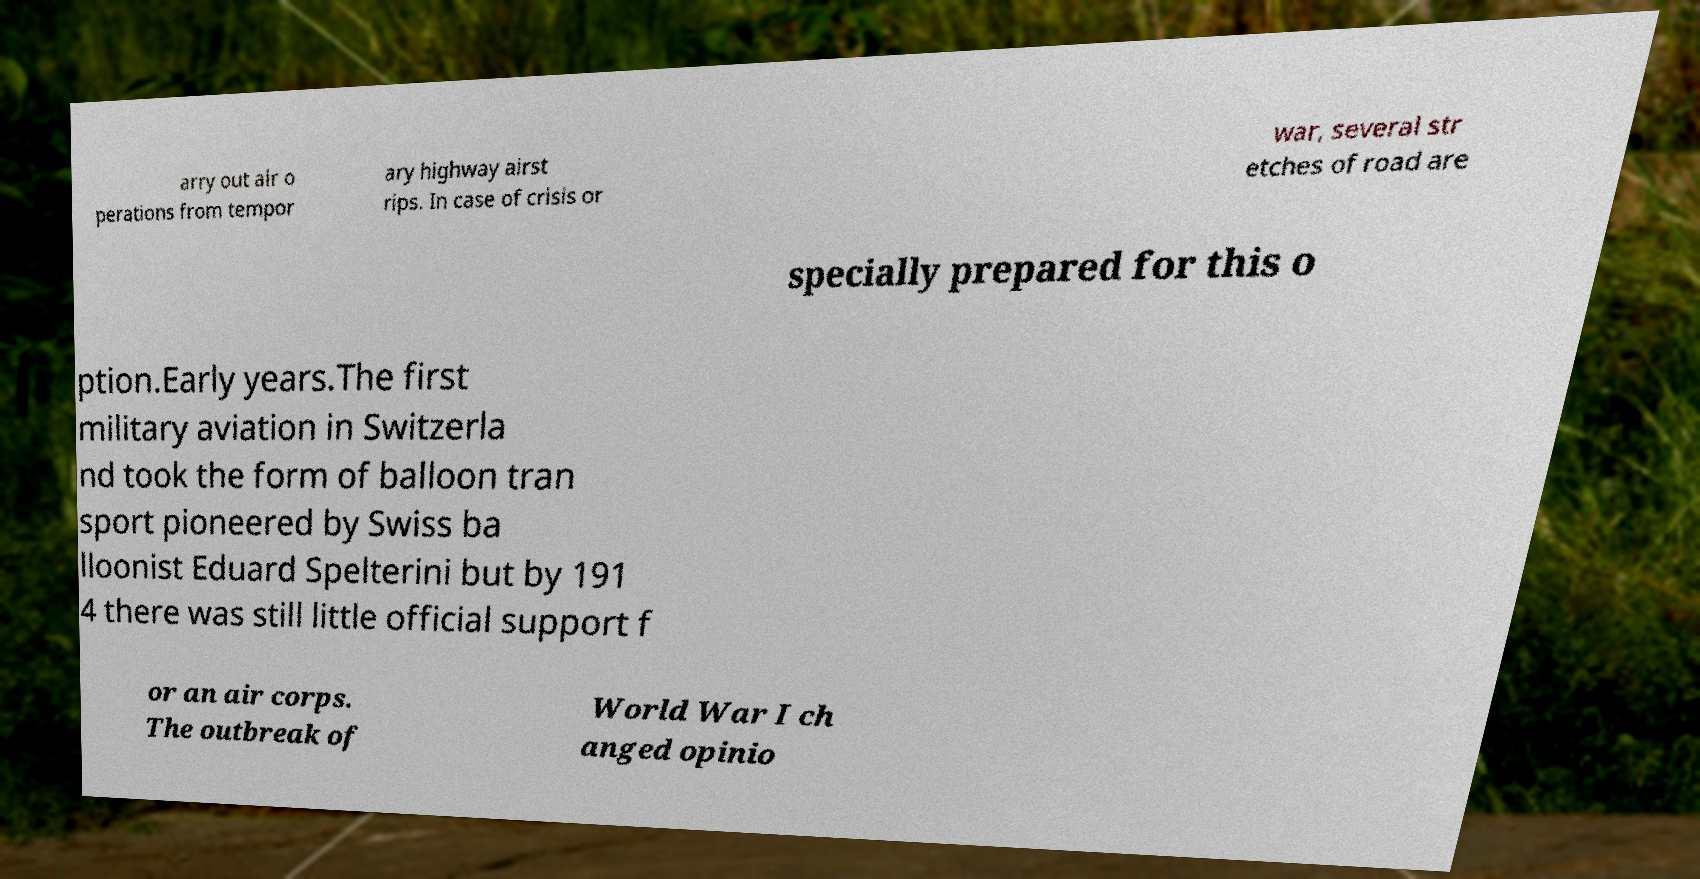Please identify and transcribe the text found in this image. arry out air o perations from tempor ary highway airst rips. In case of crisis or war, several str etches of road are specially prepared for this o ption.Early years.The first military aviation in Switzerla nd took the form of balloon tran sport pioneered by Swiss ba lloonist Eduard Spelterini but by 191 4 there was still little official support f or an air corps. The outbreak of World War I ch anged opinio 